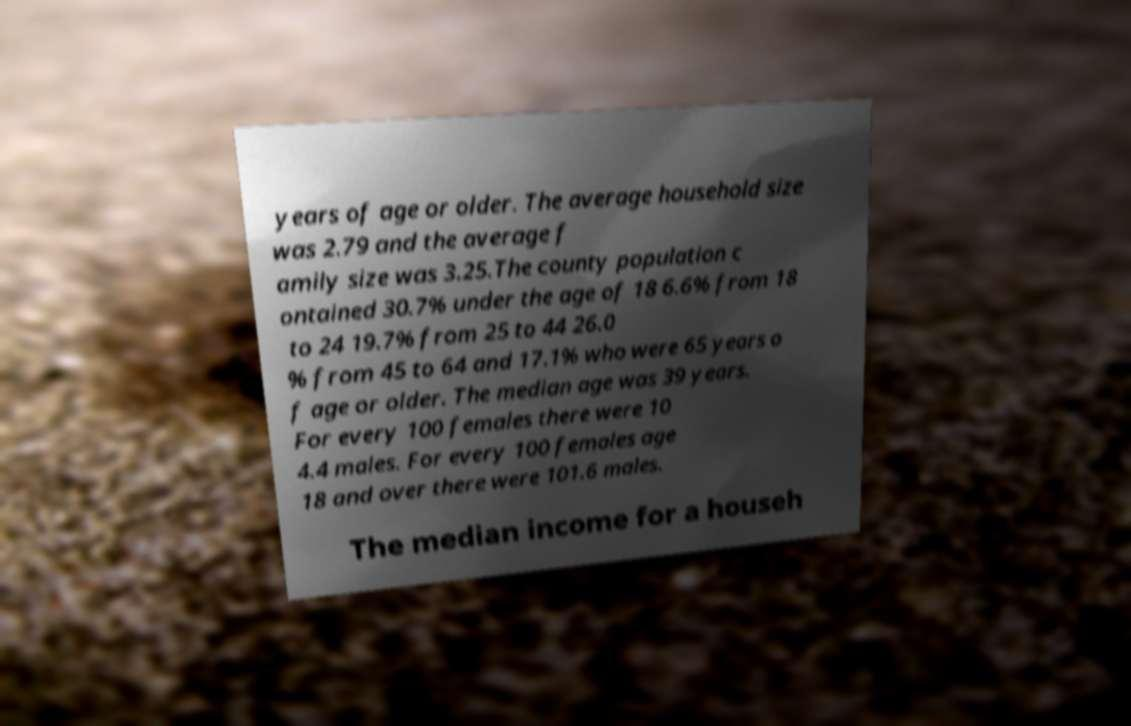Could you assist in decoding the text presented in this image and type it out clearly? years of age or older. The average household size was 2.79 and the average f amily size was 3.25.The county population c ontained 30.7% under the age of 18 6.6% from 18 to 24 19.7% from 25 to 44 26.0 % from 45 to 64 and 17.1% who were 65 years o f age or older. The median age was 39 years. For every 100 females there were 10 4.4 males. For every 100 females age 18 and over there were 101.6 males. The median income for a househ 